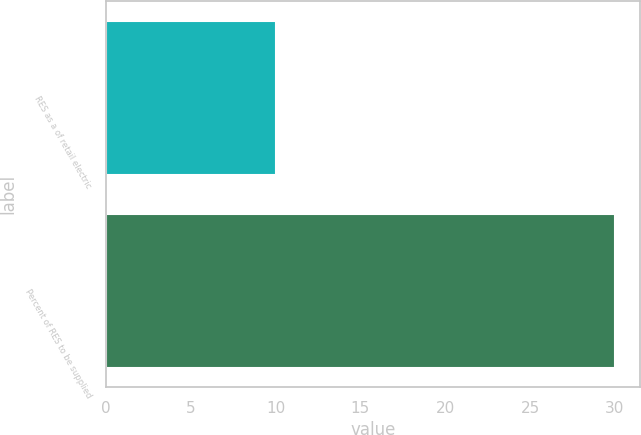Convert chart. <chart><loc_0><loc_0><loc_500><loc_500><bar_chart><fcel>RES as a of retail electric<fcel>Percent of RES to be supplied<nl><fcel>10<fcel>30<nl></chart> 